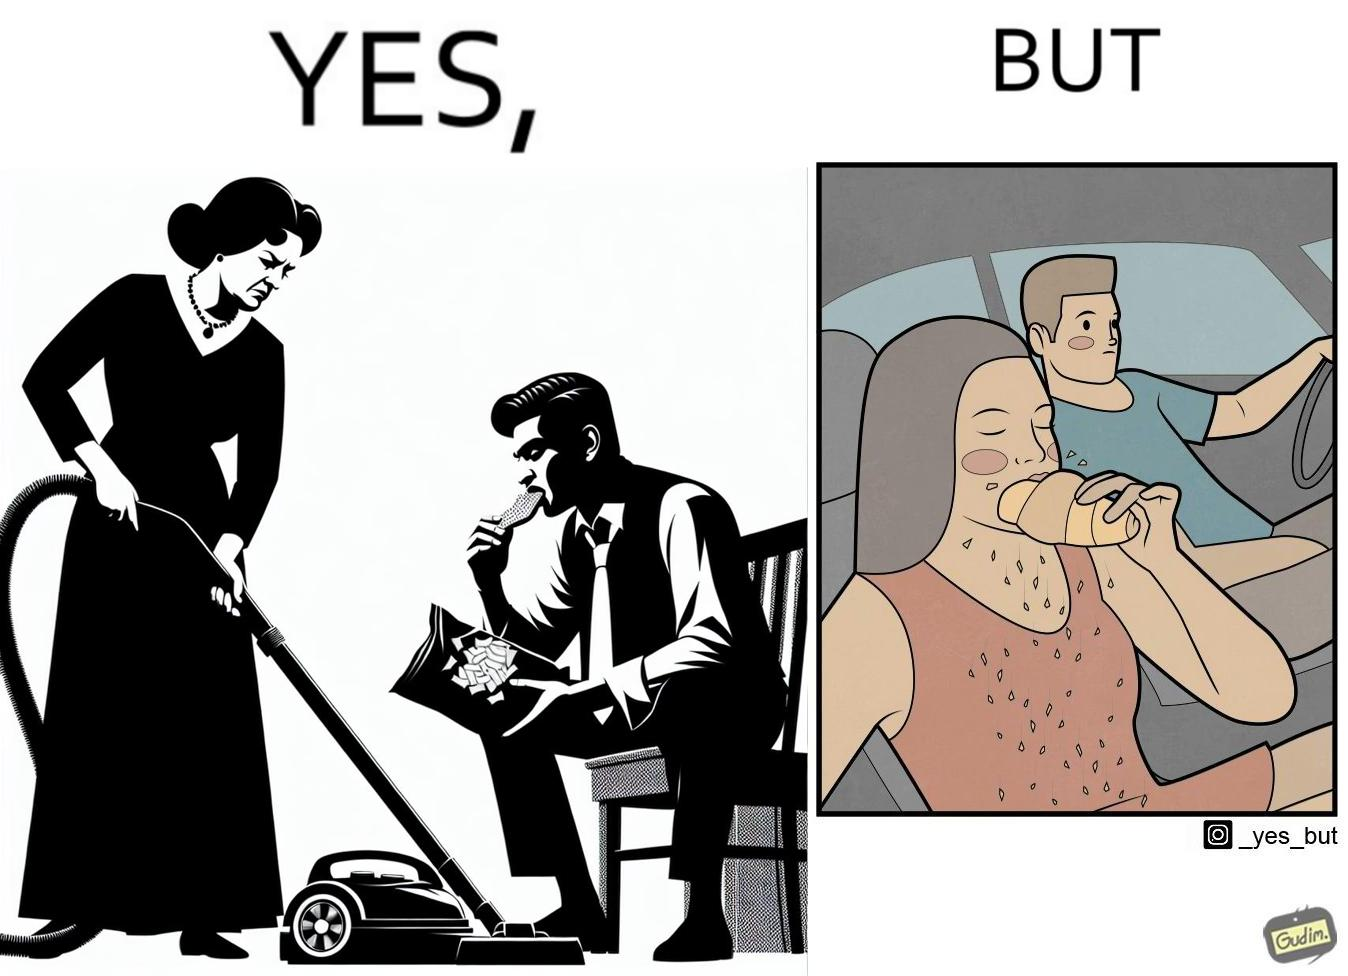Provide a description of this image. The image is ironic, because in the left image she is seen how sincere she is about keeping her home clean but in the right image she forgets these principles while travelling in the car 